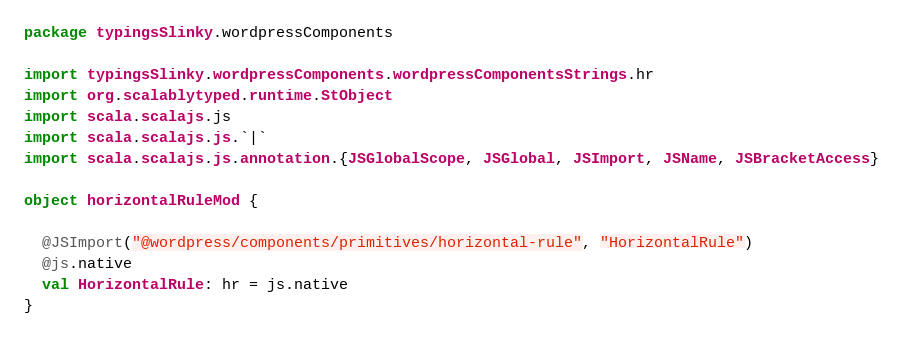Convert code to text. <code><loc_0><loc_0><loc_500><loc_500><_Scala_>package typingsSlinky.wordpressComponents

import typingsSlinky.wordpressComponents.wordpressComponentsStrings.hr
import org.scalablytyped.runtime.StObject
import scala.scalajs.js
import scala.scalajs.js.`|`
import scala.scalajs.js.annotation.{JSGlobalScope, JSGlobal, JSImport, JSName, JSBracketAccess}

object horizontalRuleMod {
  
  @JSImport("@wordpress/components/primitives/horizontal-rule", "HorizontalRule")
  @js.native
  val HorizontalRule: hr = js.native
}
</code> 